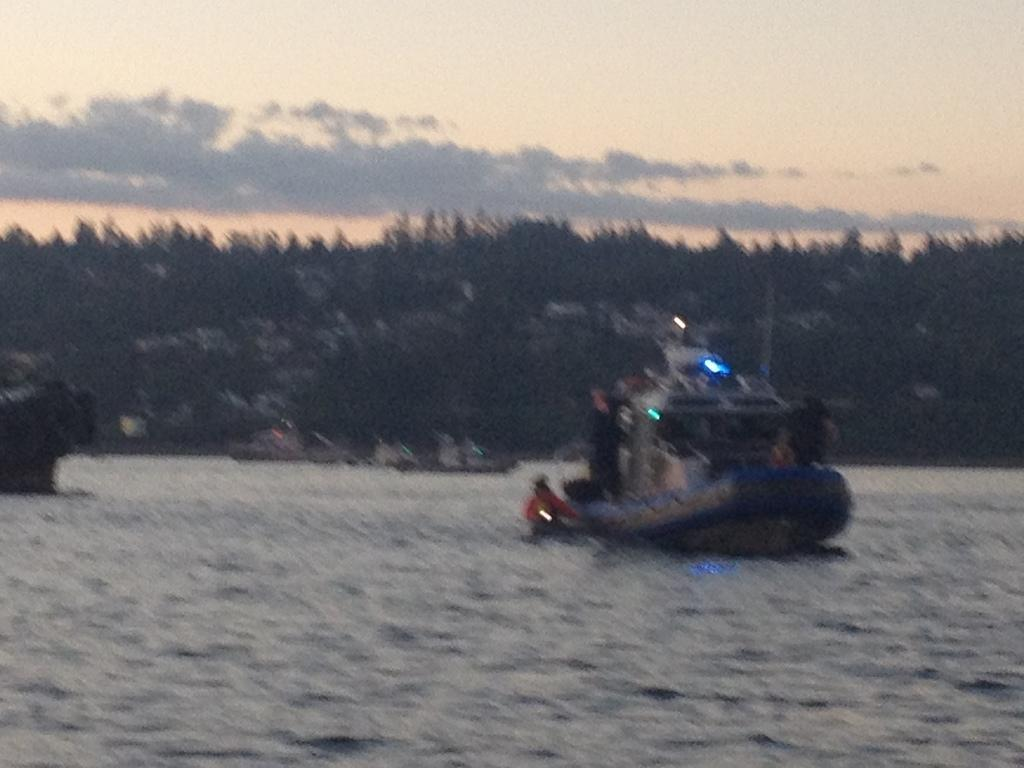What is located on the right side of the image? There is a boat in the water on the right side of the image. What can be seen inside the boat? There are people in the boat. What is visible in the background of the image? Trees are visible in the background of the image. What is visible at the top of the image? The sky is visible at the top of the image. Can you hear the kite crying in the image? There is no kite present in the image, so it cannot be heard or seen. 